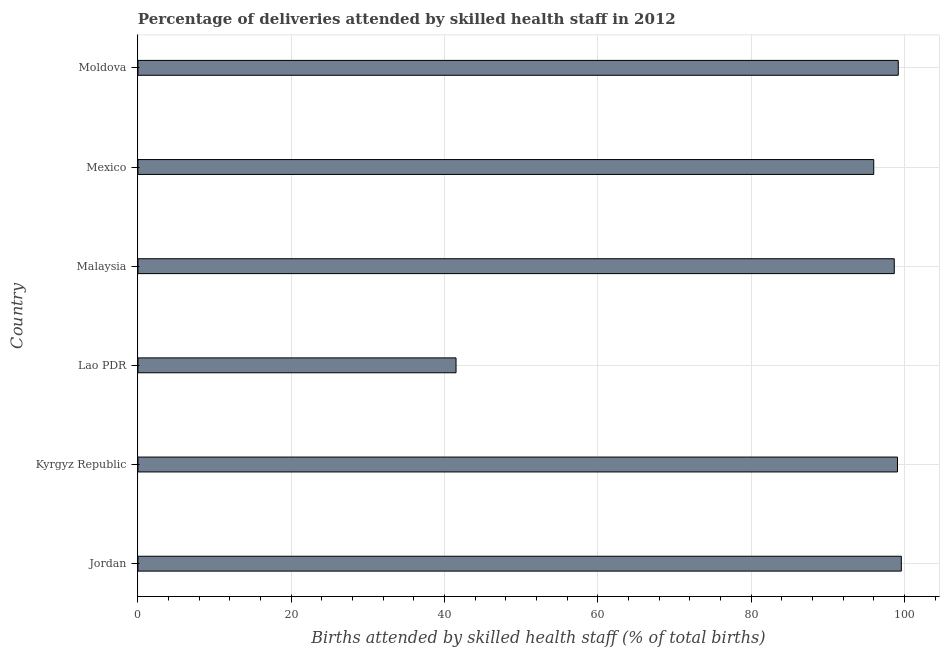Does the graph contain any zero values?
Offer a terse response. No. What is the title of the graph?
Ensure brevity in your answer.  Percentage of deliveries attended by skilled health staff in 2012. What is the label or title of the X-axis?
Keep it short and to the point. Births attended by skilled health staff (% of total births). What is the label or title of the Y-axis?
Offer a terse response. Country. What is the number of births attended by skilled health staff in Kyrgyz Republic?
Ensure brevity in your answer.  99.1. Across all countries, what is the maximum number of births attended by skilled health staff?
Your response must be concise. 99.6. Across all countries, what is the minimum number of births attended by skilled health staff?
Make the answer very short. 41.5. In which country was the number of births attended by skilled health staff maximum?
Your answer should be compact. Jordan. In which country was the number of births attended by skilled health staff minimum?
Provide a short and direct response. Lao PDR. What is the sum of the number of births attended by skilled health staff?
Make the answer very short. 534.08. What is the difference between the number of births attended by skilled health staff in Jordan and Moldova?
Your answer should be compact. 0.4. What is the average number of births attended by skilled health staff per country?
Provide a short and direct response. 89.01. What is the median number of births attended by skilled health staff?
Offer a very short reply. 98.89. Is the number of births attended by skilled health staff in Mexico less than that in Moldova?
Ensure brevity in your answer.  Yes. Is the difference between the number of births attended by skilled health staff in Lao PDR and Mexico greater than the difference between any two countries?
Make the answer very short. No. What is the difference between the highest and the lowest number of births attended by skilled health staff?
Your answer should be compact. 58.1. In how many countries, is the number of births attended by skilled health staff greater than the average number of births attended by skilled health staff taken over all countries?
Your response must be concise. 5. Are all the bars in the graph horizontal?
Offer a very short reply. Yes. Are the values on the major ticks of X-axis written in scientific E-notation?
Your response must be concise. No. What is the Births attended by skilled health staff (% of total births) of Jordan?
Offer a very short reply. 99.6. What is the Births attended by skilled health staff (% of total births) of Kyrgyz Republic?
Your response must be concise. 99.1. What is the Births attended by skilled health staff (% of total births) in Lao PDR?
Provide a succinct answer. 41.5. What is the Births attended by skilled health staff (% of total births) of Malaysia?
Your response must be concise. 98.68. What is the Births attended by skilled health staff (% of total births) in Mexico?
Provide a short and direct response. 96. What is the Births attended by skilled health staff (% of total births) of Moldova?
Make the answer very short. 99.2. What is the difference between the Births attended by skilled health staff (% of total births) in Jordan and Kyrgyz Republic?
Your answer should be very brief. 0.5. What is the difference between the Births attended by skilled health staff (% of total births) in Jordan and Lao PDR?
Provide a succinct answer. 58.1. What is the difference between the Births attended by skilled health staff (% of total births) in Jordan and Malaysia?
Ensure brevity in your answer.  0.92. What is the difference between the Births attended by skilled health staff (% of total births) in Jordan and Mexico?
Keep it short and to the point. 3.6. What is the difference between the Births attended by skilled health staff (% of total births) in Kyrgyz Republic and Lao PDR?
Offer a very short reply. 57.6. What is the difference between the Births attended by skilled health staff (% of total births) in Kyrgyz Republic and Malaysia?
Your answer should be very brief. 0.42. What is the difference between the Births attended by skilled health staff (% of total births) in Kyrgyz Republic and Mexico?
Keep it short and to the point. 3.1. What is the difference between the Births attended by skilled health staff (% of total births) in Lao PDR and Malaysia?
Your answer should be compact. -57.18. What is the difference between the Births attended by skilled health staff (% of total births) in Lao PDR and Mexico?
Offer a terse response. -54.5. What is the difference between the Births attended by skilled health staff (% of total births) in Lao PDR and Moldova?
Offer a terse response. -57.7. What is the difference between the Births attended by skilled health staff (% of total births) in Malaysia and Mexico?
Offer a terse response. 2.68. What is the difference between the Births attended by skilled health staff (% of total births) in Malaysia and Moldova?
Your answer should be compact. -0.52. What is the difference between the Births attended by skilled health staff (% of total births) in Mexico and Moldova?
Make the answer very short. -3.2. What is the ratio of the Births attended by skilled health staff (% of total births) in Jordan to that in Kyrgyz Republic?
Provide a succinct answer. 1. What is the ratio of the Births attended by skilled health staff (% of total births) in Jordan to that in Malaysia?
Your response must be concise. 1.01. What is the ratio of the Births attended by skilled health staff (% of total births) in Kyrgyz Republic to that in Lao PDR?
Provide a succinct answer. 2.39. What is the ratio of the Births attended by skilled health staff (% of total births) in Kyrgyz Republic to that in Mexico?
Ensure brevity in your answer.  1.03. What is the ratio of the Births attended by skilled health staff (% of total births) in Lao PDR to that in Malaysia?
Give a very brief answer. 0.42. What is the ratio of the Births attended by skilled health staff (% of total births) in Lao PDR to that in Mexico?
Offer a very short reply. 0.43. What is the ratio of the Births attended by skilled health staff (% of total births) in Lao PDR to that in Moldova?
Give a very brief answer. 0.42. What is the ratio of the Births attended by skilled health staff (% of total births) in Malaysia to that in Mexico?
Offer a terse response. 1.03. What is the ratio of the Births attended by skilled health staff (% of total births) in Mexico to that in Moldova?
Make the answer very short. 0.97. 